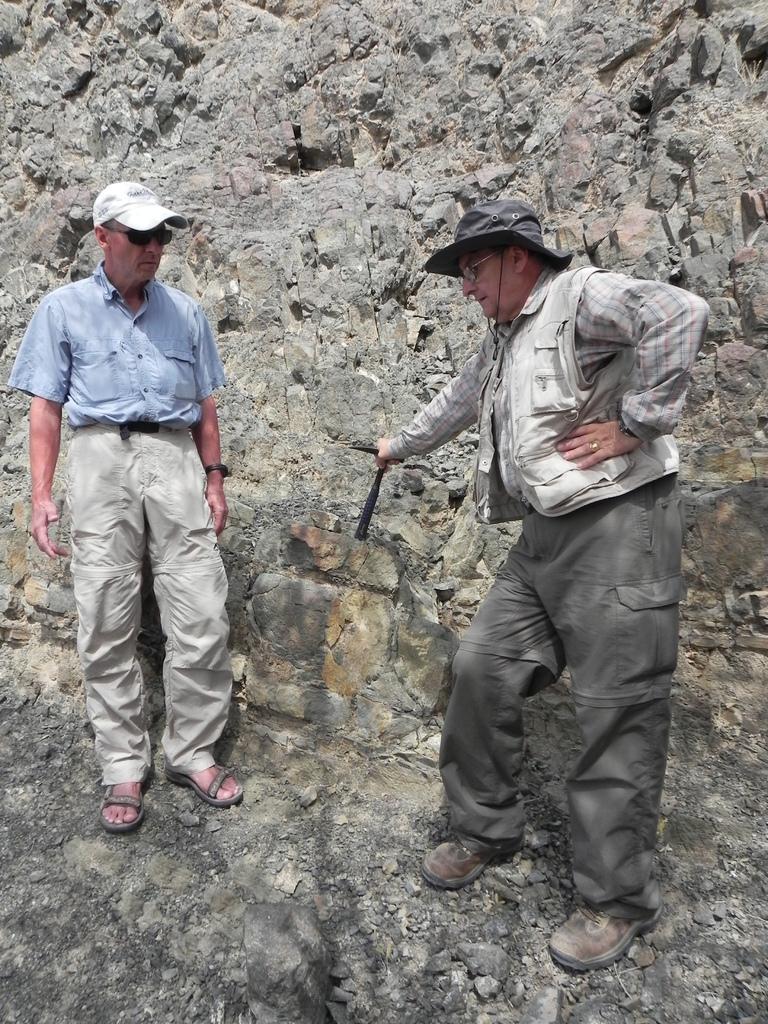Please provide a concise description of this image. In this picture I can see couple of men standing on the rock and both of them wore caps on their heads and a man holding a metal instrument in his hand. 